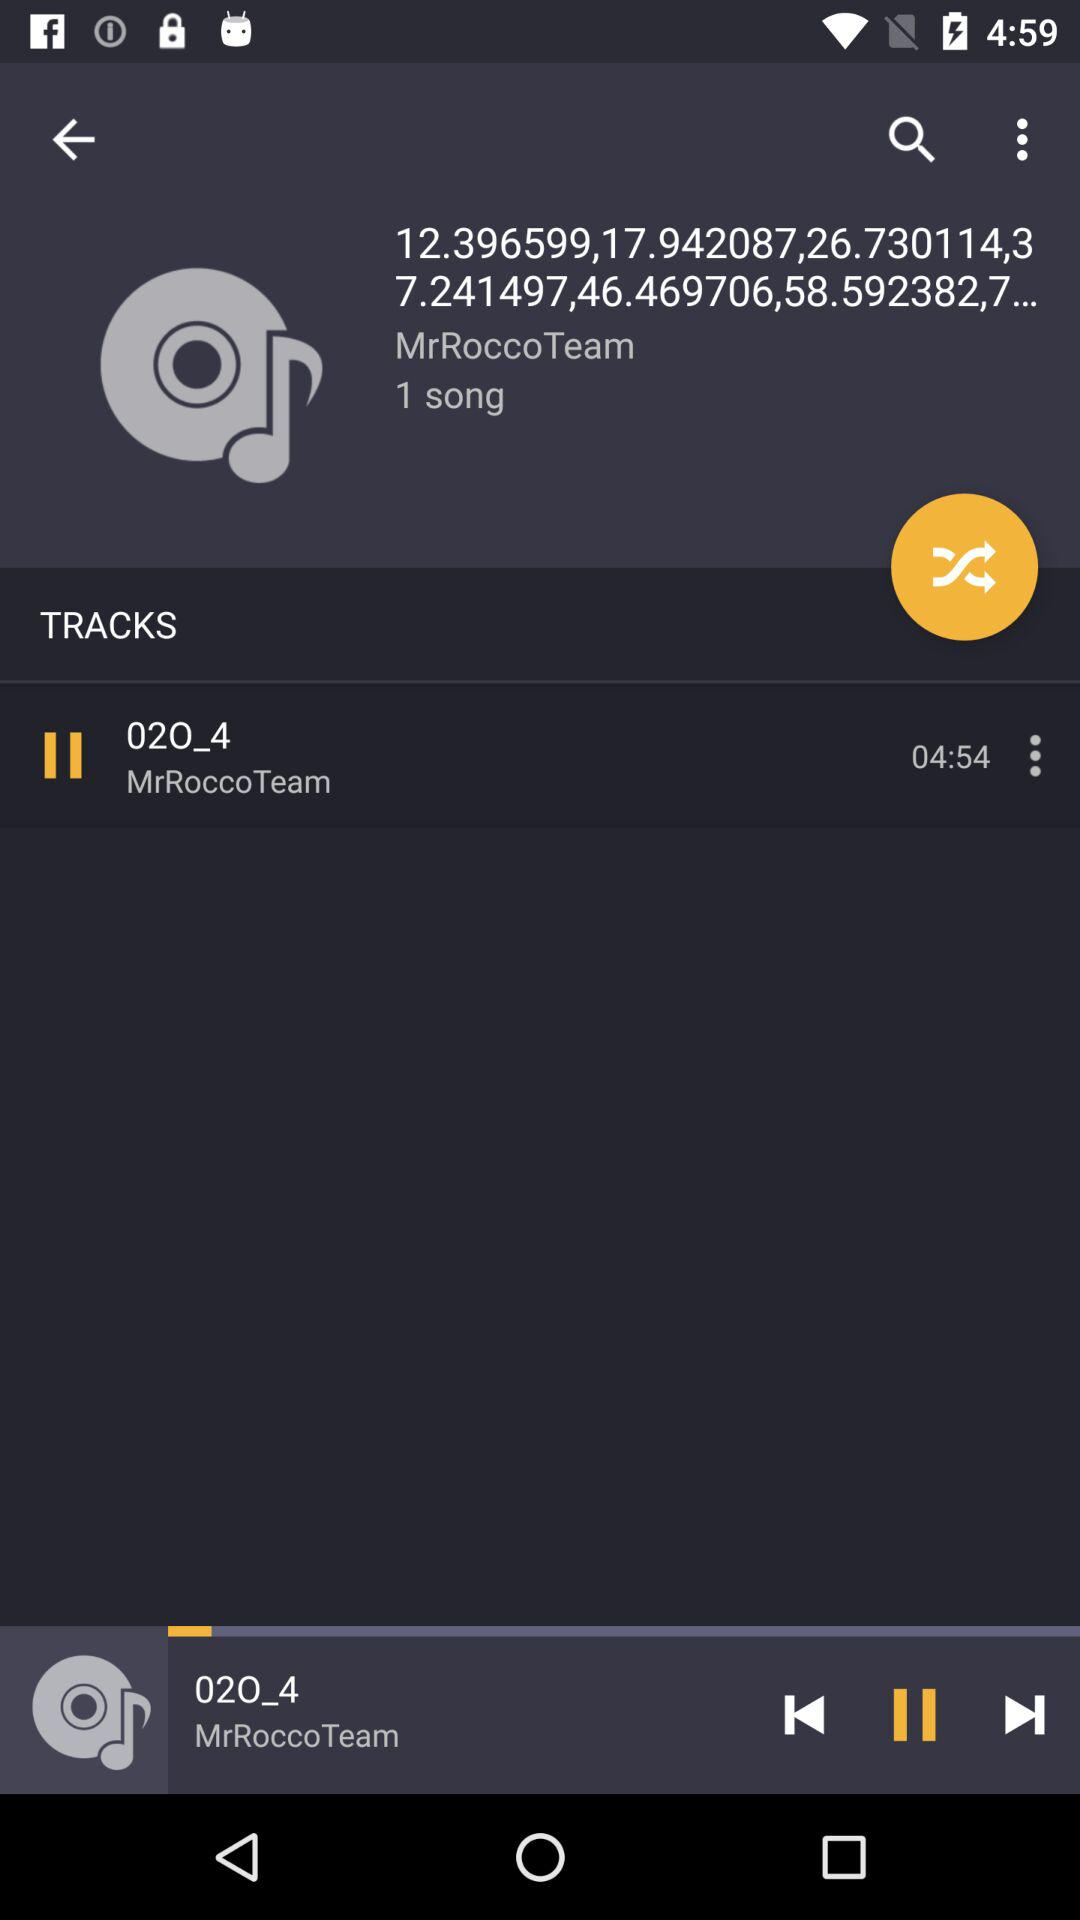What is the length of the current song?
Answer the question using a single word or phrase. 04:54 